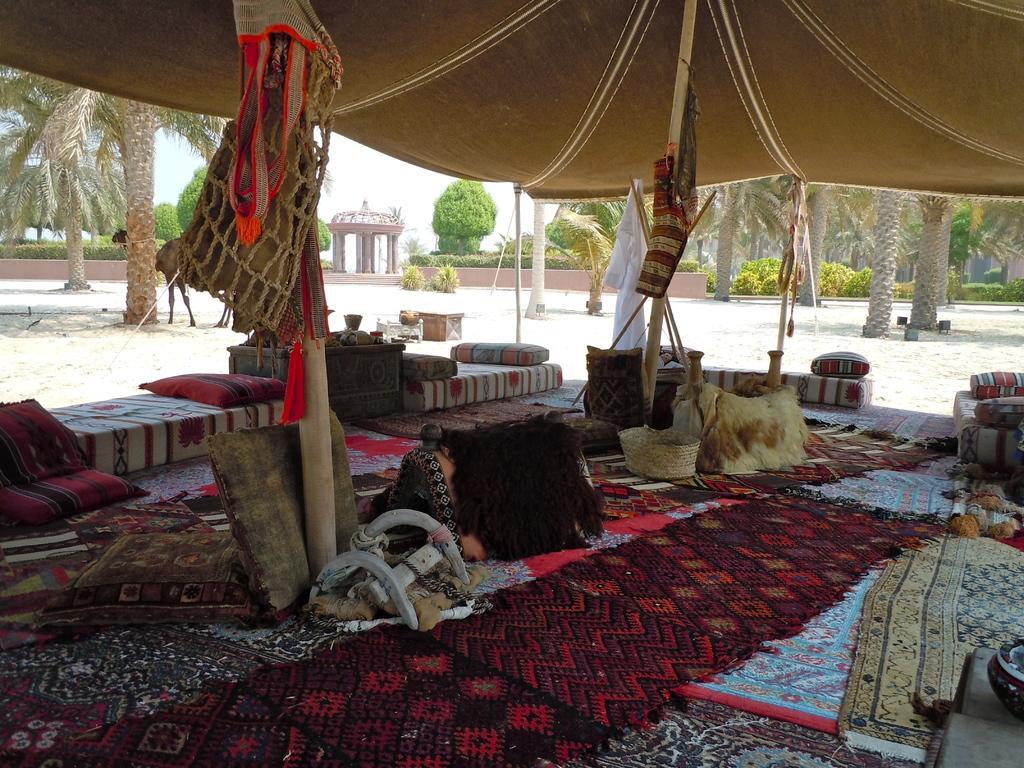Describe this image in one or two sentences. In this picture we can see few pillows, carpets, beds and other things under the tent, in the background we can see few trees. 